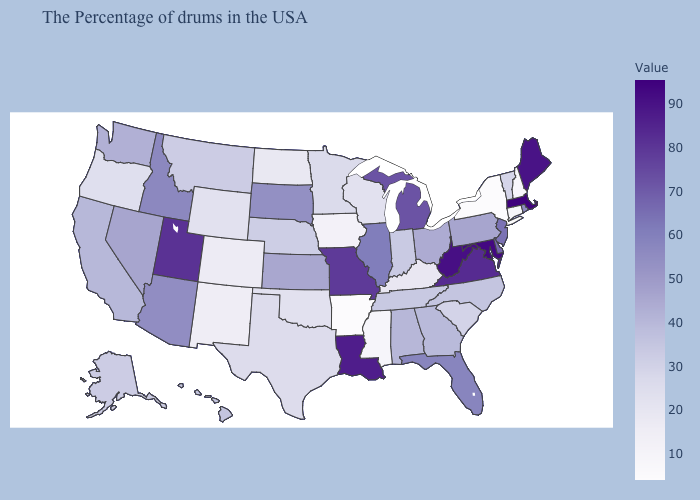Does Alaska have a higher value than North Dakota?
Be succinct. Yes. Which states have the lowest value in the West?
Keep it brief. New Mexico. Does Massachusetts have the highest value in the Northeast?
Write a very short answer. Yes. 